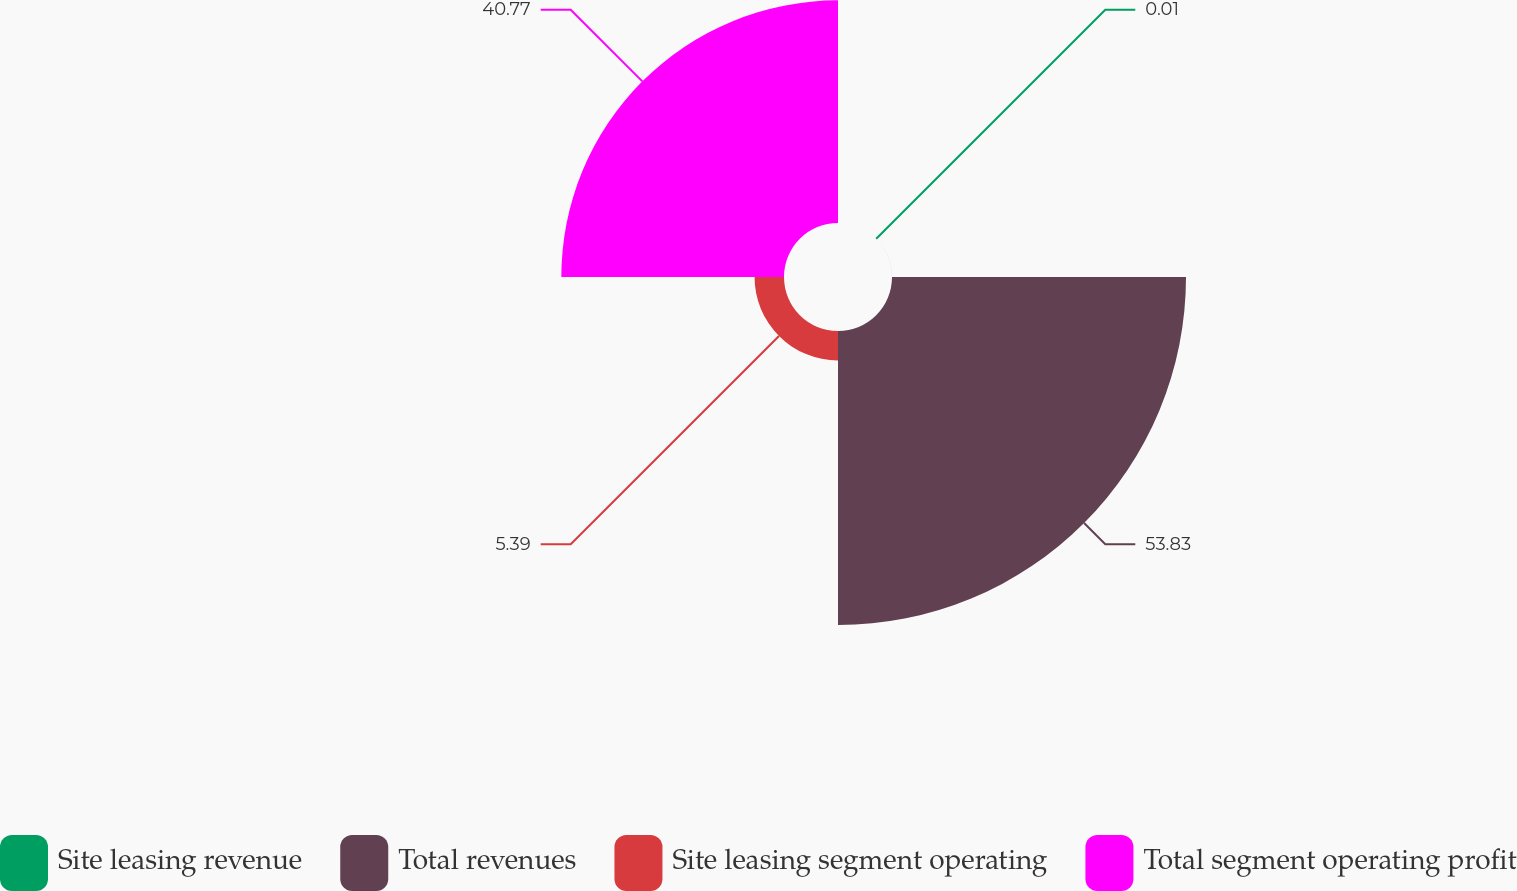Convert chart. <chart><loc_0><loc_0><loc_500><loc_500><pie_chart><fcel>Site leasing revenue<fcel>Total revenues<fcel>Site leasing segment operating<fcel>Total segment operating profit<nl><fcel>0.01%<fcel>53.83%<fcel>5.39%<fcel>40.77%<nl></chart> 